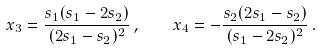<formula> <loc_0><loc_0><loc_500><loc_500>x _ { 3 } = \frac { s _ { 1 } ( s _ { 1 } - 2 s _ { 2 } ) } { ( 2 s _ { 1 } - s _ { 2 } ) ^ { 2 } } \, , \quad x _ { 4 } = - \frac { s _ { 2 } ( 2 s _ { 1 } - s _ { 2 } ) } { ( s _ { 1 } - 2 s _ { 2 } ) ^ { 2 } } \, .</formula> 